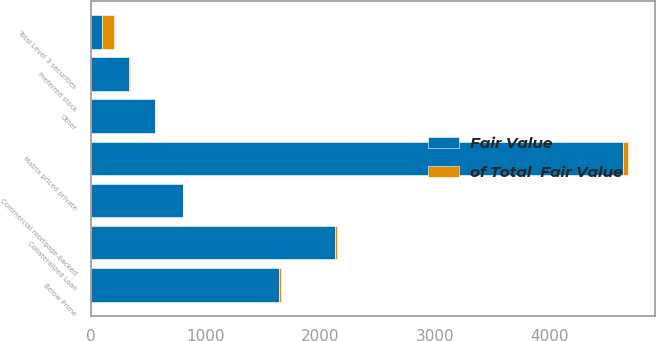<chart> <loc_0><loc_0><loc_500><loc_500><stacked_bar_chart><ecel><fcel>Below Prime<fcel>Collateralized Loan<fcel>Other<fcel>Matrix priced private<fcel>Commercial mortgage-backed<fcel>Preferred stock<fcel>Total Level 3 securities<nl><fcel>Fair Value<fcel>1643<fcel>2131<fcel>560<fcel>4641<fcel>802<fcel>337<fcel>100<nl><fcel>of Total  Fair Value<fcel>13.3<fcel>17.3<fcel>4.5<fcel>37.6<fcel>6.5<fcel>2.7<fcel>100<nl></chart> 